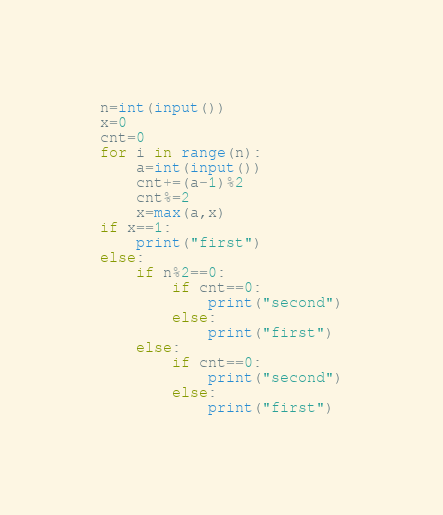Convert code to text. <code><loc_0><loc_0><loc_500><loc_500><_Python_>n=int(input())
x=0
cnt=0
for i in range(n):
    a=int(input())
    cnt+=(a-1)%2
    cnt%=2
    x=max(a,x)
if x==1:
    print("first")
else:
    if n%2==0:
        if cnt==0:
            print("second")
        else:
            print("first")
    else:
        if cnt==0:
            print("second")
        else:
            print("first")</code> 